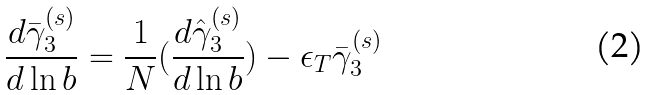<formula> <loc_0><loc_0><loc_500><loc_500>\frac { d \bar { \gamma } _ { 3 } ^ { ( s ) } } { d \ln b } = \frac { 1 } { N } ( \frac { d \hat { \gamma } _ { 3 } ^ { ( s ) } } { d \ln b } ) - \epsilon _ { T } \bar { \gamma } _ { 3 } ^ { ( s ) }</formula> 